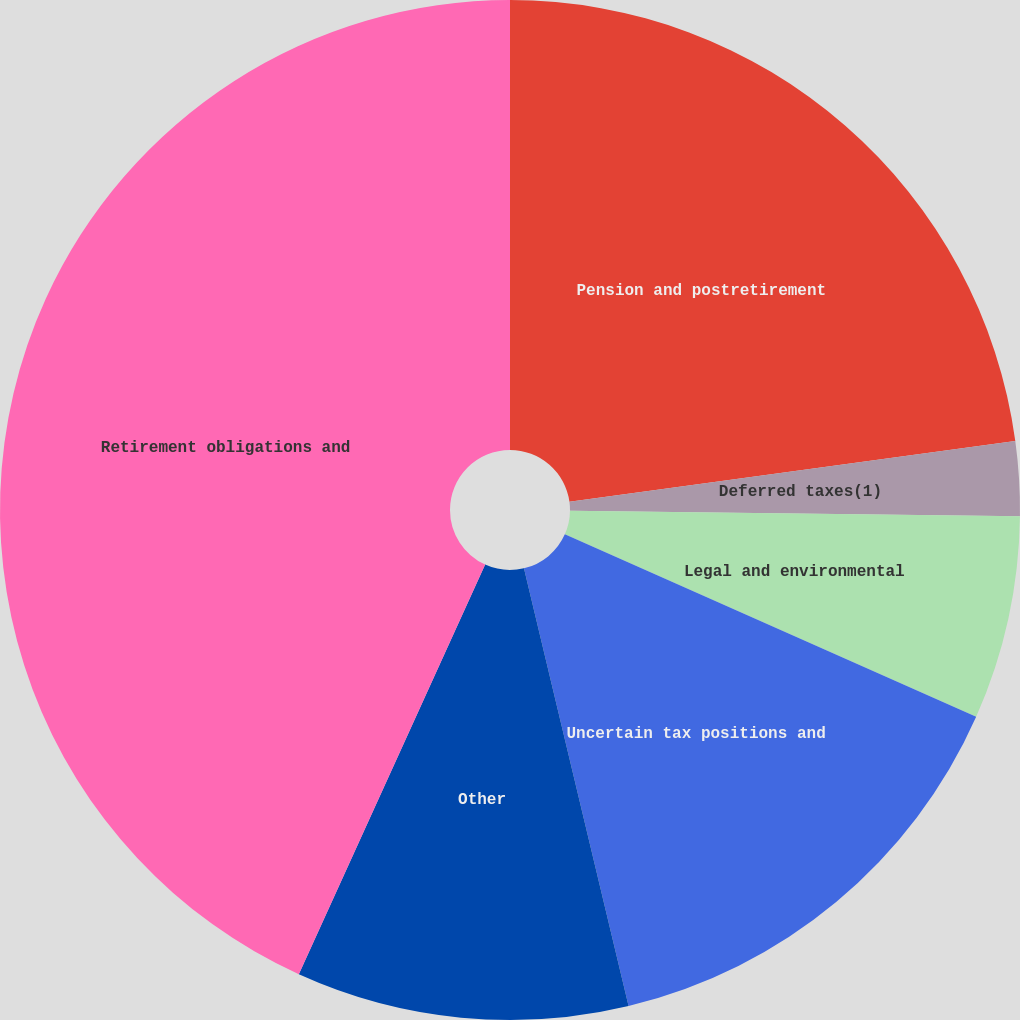Convert chart. <chart><loc_0><loc_0><loc_500><loc_500><pie_chart><fcel>Pension and postretirement<fcel>Deferred taxes(1)<fcel>Legal and environmental<fcel>Uncertain tax positions and<fcel>Other<fcel>Retirement obligations and<nl><fcel>22.84%<fcel>2.36%<fcel>6.45%<fcel>14.62%<fcel>10.53%<fcel>43.21%<nl></chart> 